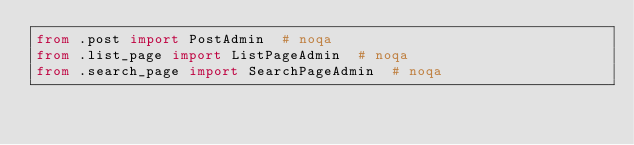<code> <loc_0><loc_0><loc_500><loc_500><_Python_>from .post import PostAdmin  # noqa
from .list_page import ListPageAdmin  # noqa
from .search_page import SearchPageAdmin  # noqa
</code> 